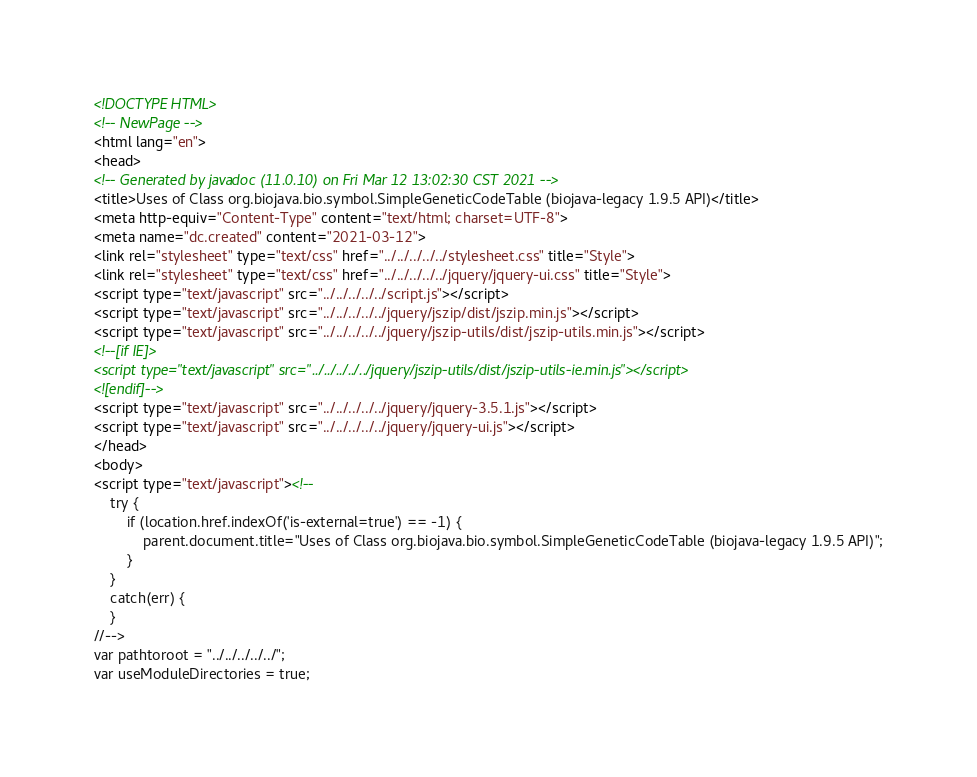Convert code to text. <code><loc_0><loc_0><loc_500><loc_500><_HTML_><!DOCTYPE HTML>
<!-- NewPage -->
<html lang="en">
<head>
<!-- Generated by javadoc (11.0.10) on Fri Mar 12 13:02:30 CST 2021 -->
<title>Uses of Class org.biojava.bio.symbol.SimpleGeneticCodeTable (biojava-legacy 1.9.5 API)</title>
<meta http-equiv="Content-Type" content="text/html; charset=UTF-8">
<meta name="dc.created" content="2021-03-12">
<link rel="stylesheet" type="text/css" href="../../../../../stylesheet.css" title="Style">
<link rel="stylesheet" type="text/css" href="../../../../../jquery/jquery-ui.css" title="Style">
<script type="text/javascript" src="../../../../../script.js"></script>
<script type="text/javascript" src="../../../../../jquery/jszip/dist/jszip.min.js"></script>
<script type="text/javascript" src="../../../../../jquery/jszip-utils/dist/jszip-utils.min.js"></script>
<!--[if IE]>
<script type="text/javascript" src="../../../../../jquery/jszip-utils/dist/jszip-utils-ie.min.js"></script>
<![endif]-->
<script type="text/javascript" src="../../../../../jquery/jquery-3.5.1.js"></script>
<script type="text/javascript" src="../../../../../jquery/jquery-ui.js"></script>
</head>
<body>
<script type="text/javascript"><!--
    try {
        if (location.href.indexOf('is-external=true') == -1) {
            parent.document.title="Uses of Class org.biojava.bio.symbol.SimpleGeneticCodeTable (biojava-legacy 1.9.5 API)";
        }
    }
    catch(err) {
    }
//-->
var pathtoroot = "../../../../../";
var useModuleDirectories = true;</code> 